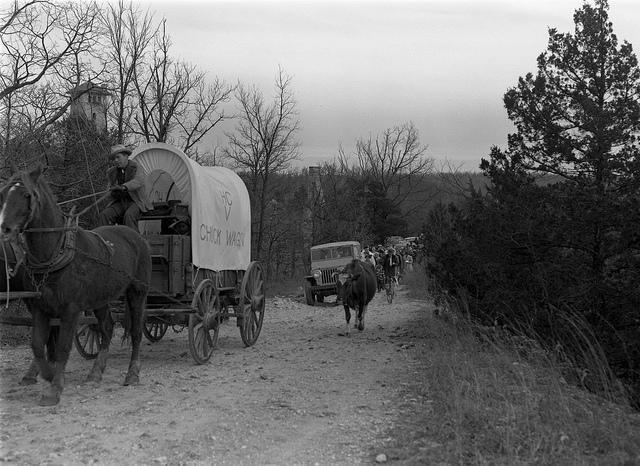How many horses are in the picture?
Give a very brief answer. 1. How many sheep are sticking their head through the fence?
Give a very brief answer. 0. 